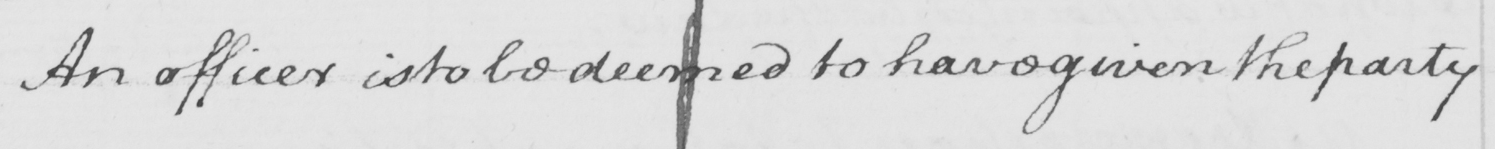Please transcribe the handwritten text in this image. An officer is to be deemed to have given the party 